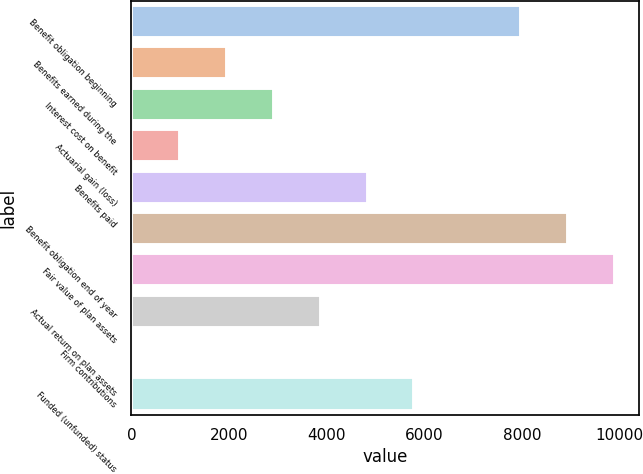<chart> <loc_0><loc_0><loc_500><loc_500><bar_chart><fcel>Benefit obligation beginning<fcel>Benefits earned during the<fcel>Interest cost on benefit<fcel>Actuarial gain (loss)<fcel>Benefits paid<fcel>Benefit obligation end of year<fcel>Fair value of plan assets<fcel>Actual return on plan assets<fcel>Firm contributions<fcel>Funded (unfunded) status<nl><fcel>7980<fcel>1961.8<fcel>2921.2<fcel>1002.4<fcel>4840<fcel>8939.4<fcel>9898.8<fcel>3880.6<fcel>43<fcel>5799.4<nl></chart> 